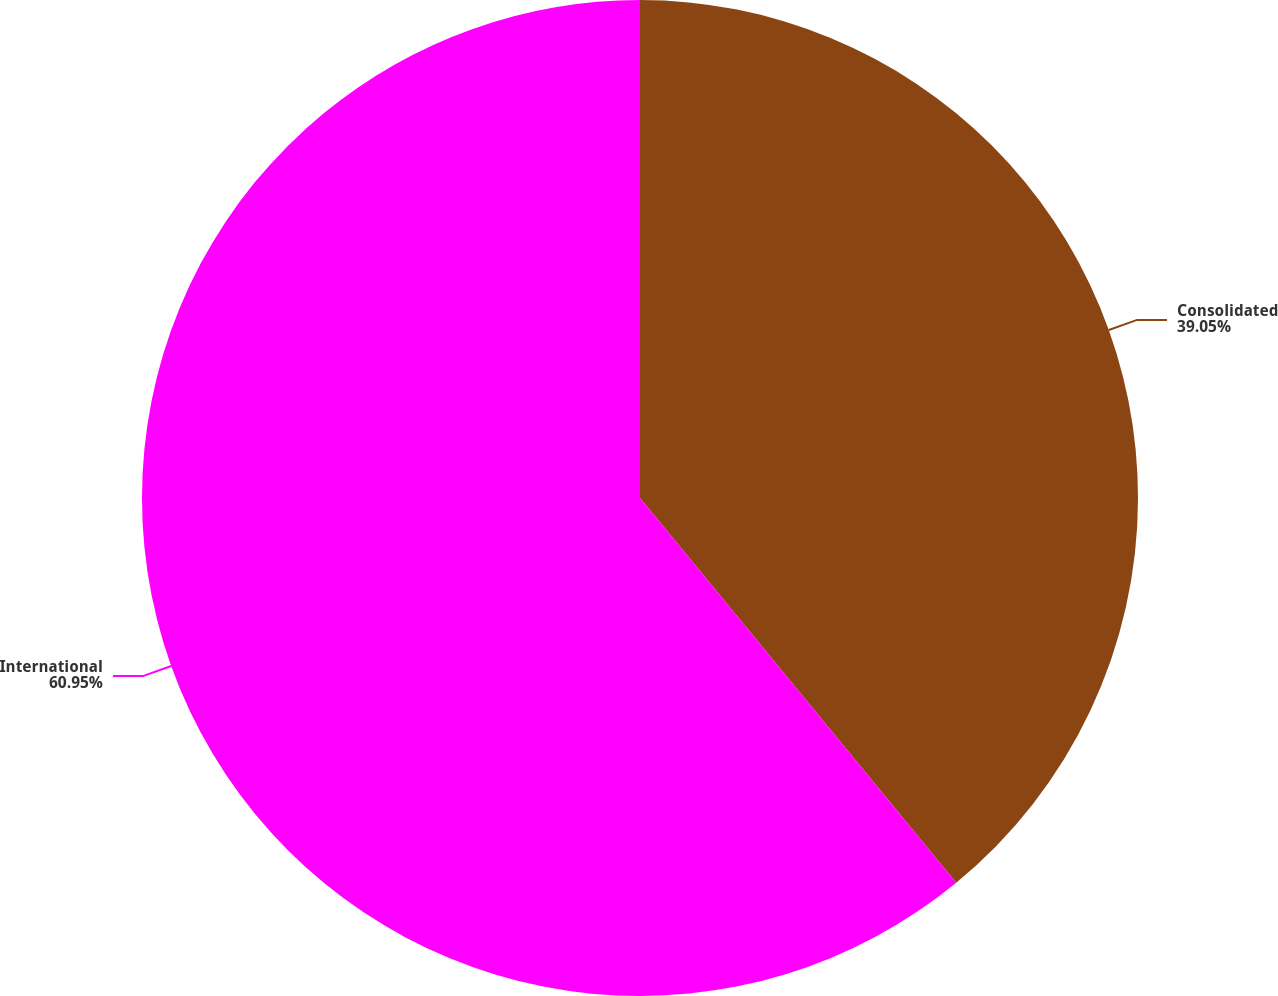<chart> <loc_0><loc_0><loc_500><loc_500><pie_chart><fcel>Consolidated<fcel>International<nl><fcel>39.05%<fcel>60.95%<nl></chart> 